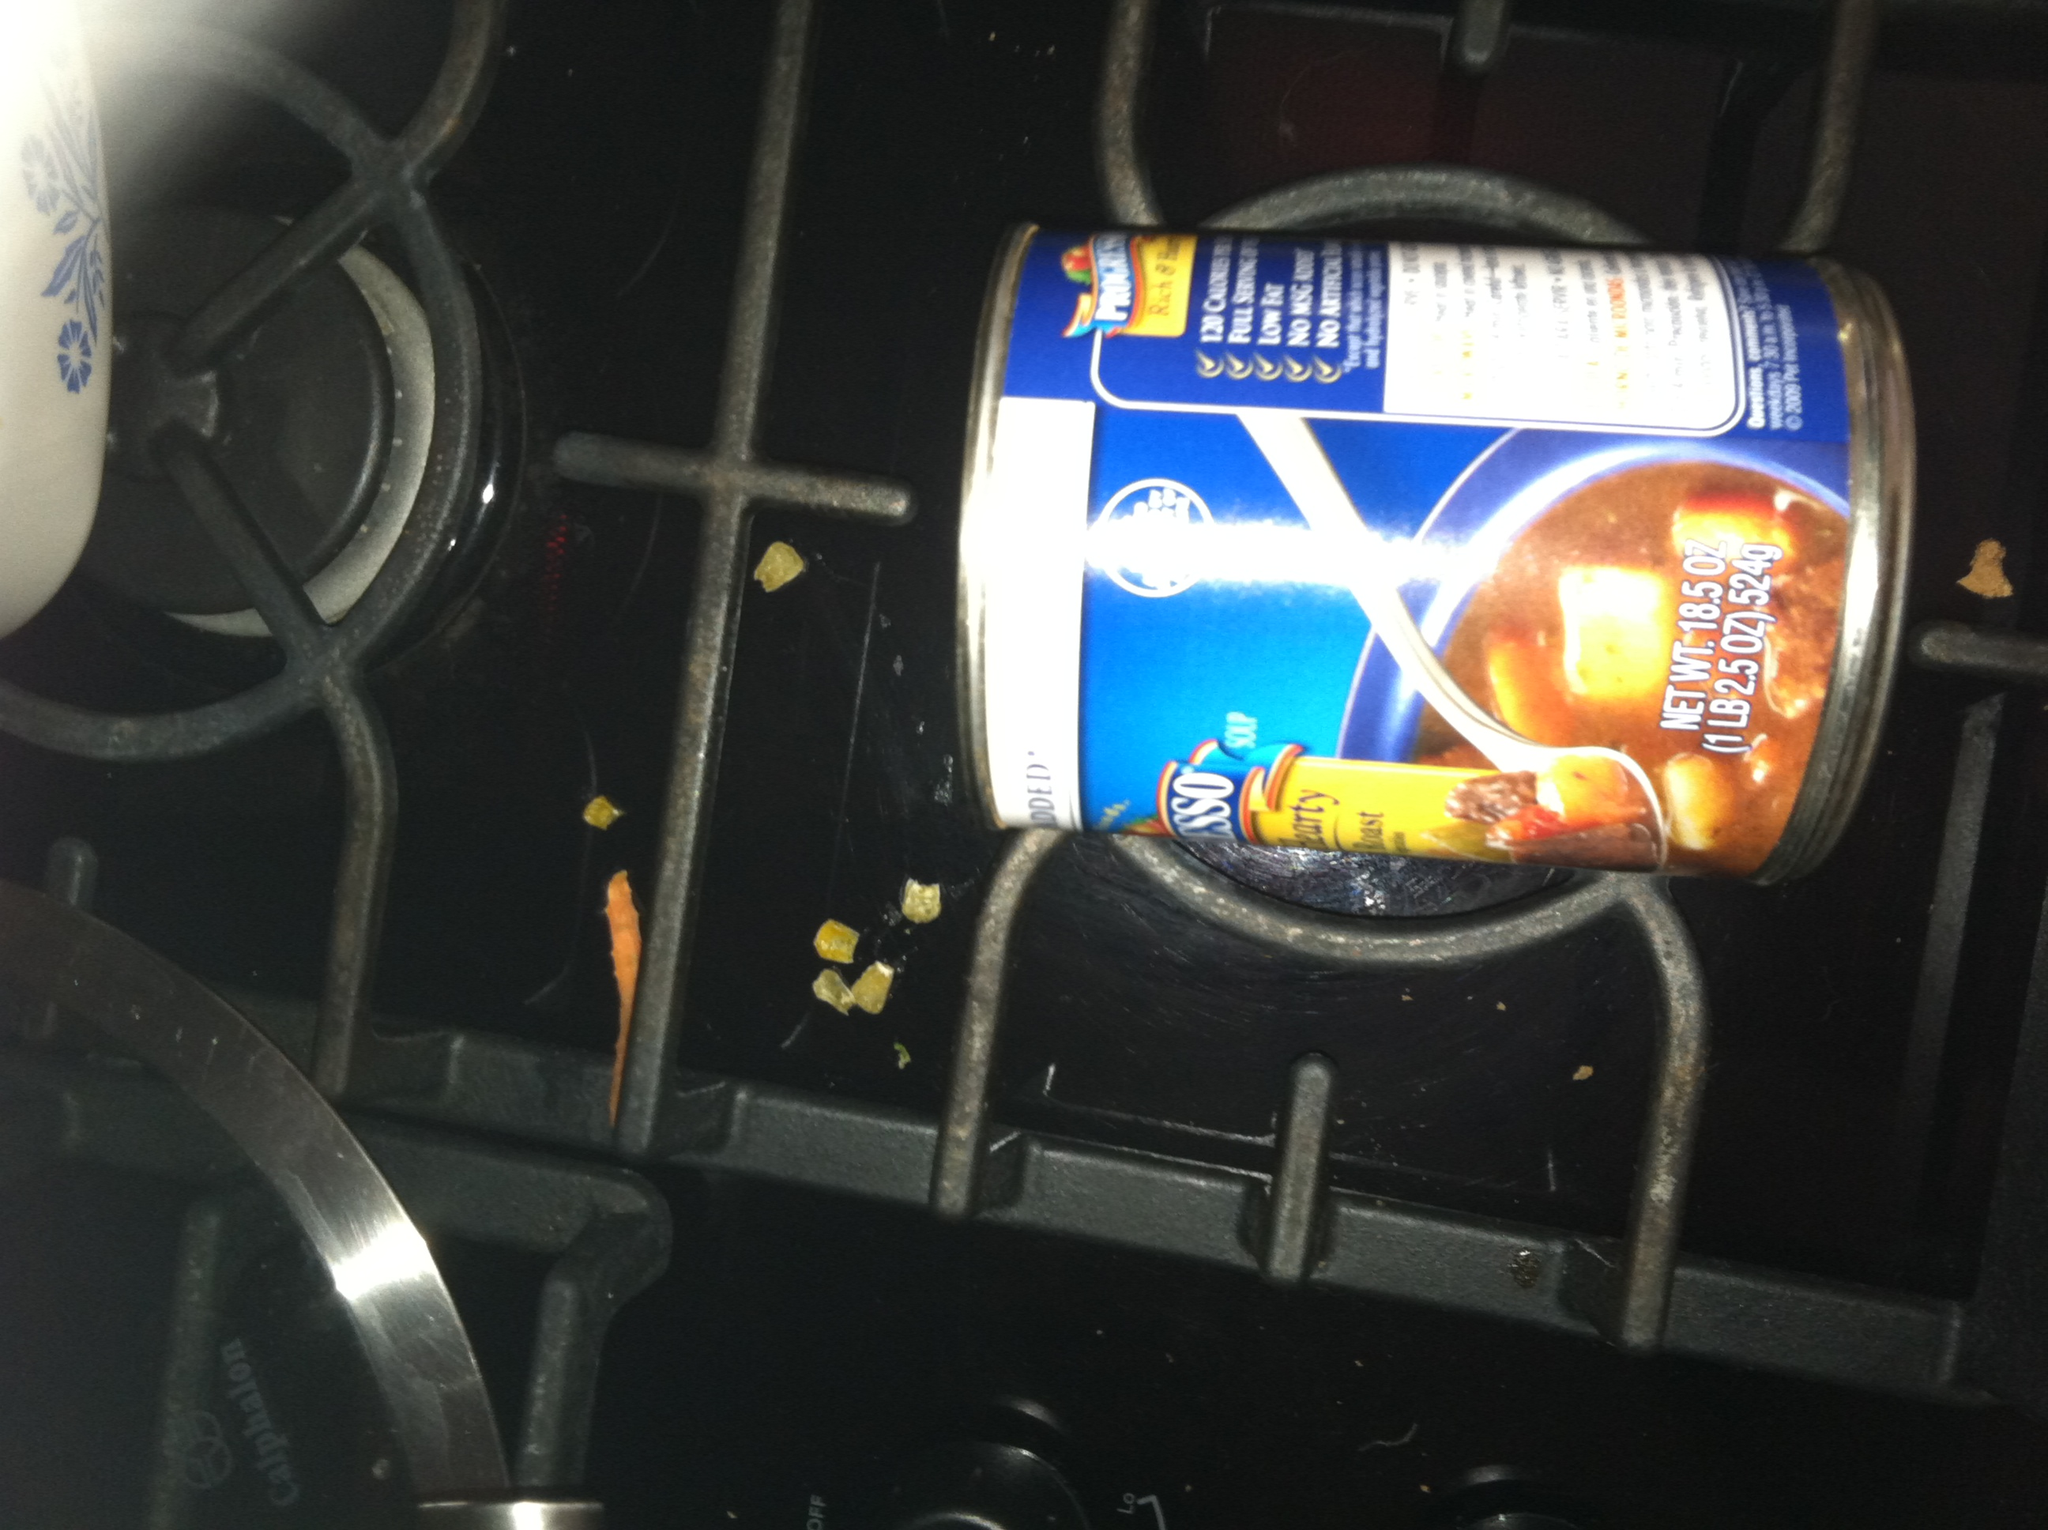What cleaning tips would you recommend for a stove that looks like the one in the image? For cleaning a stove similar to the one shown in the image, here are some effective tips:
1. Remove the grates and burner caps and soak them in soapy water for about 15-20 minutes.
2. Use a degreaser or a mixture of baking soda and water to create a paste. Apply it to any tough stains or grease spots and let it sit for a few minutes.
3. Scrub the grates, burner caps, and the stove surface using a non-abrasive sponge or brush.
4. For food debris stuck in hard-to-reach areas, use a toothpick or an old toothbrush.
5. Wipe down the stove with a clean, damp cloth, ensuring all cleaning residues are removed.
6. Dry the components completely before reassembling the grates and burner caps.
Regular maintenance and immediate clean-ups after cooking will keep the stove looking pristine and functioning efficiently. 